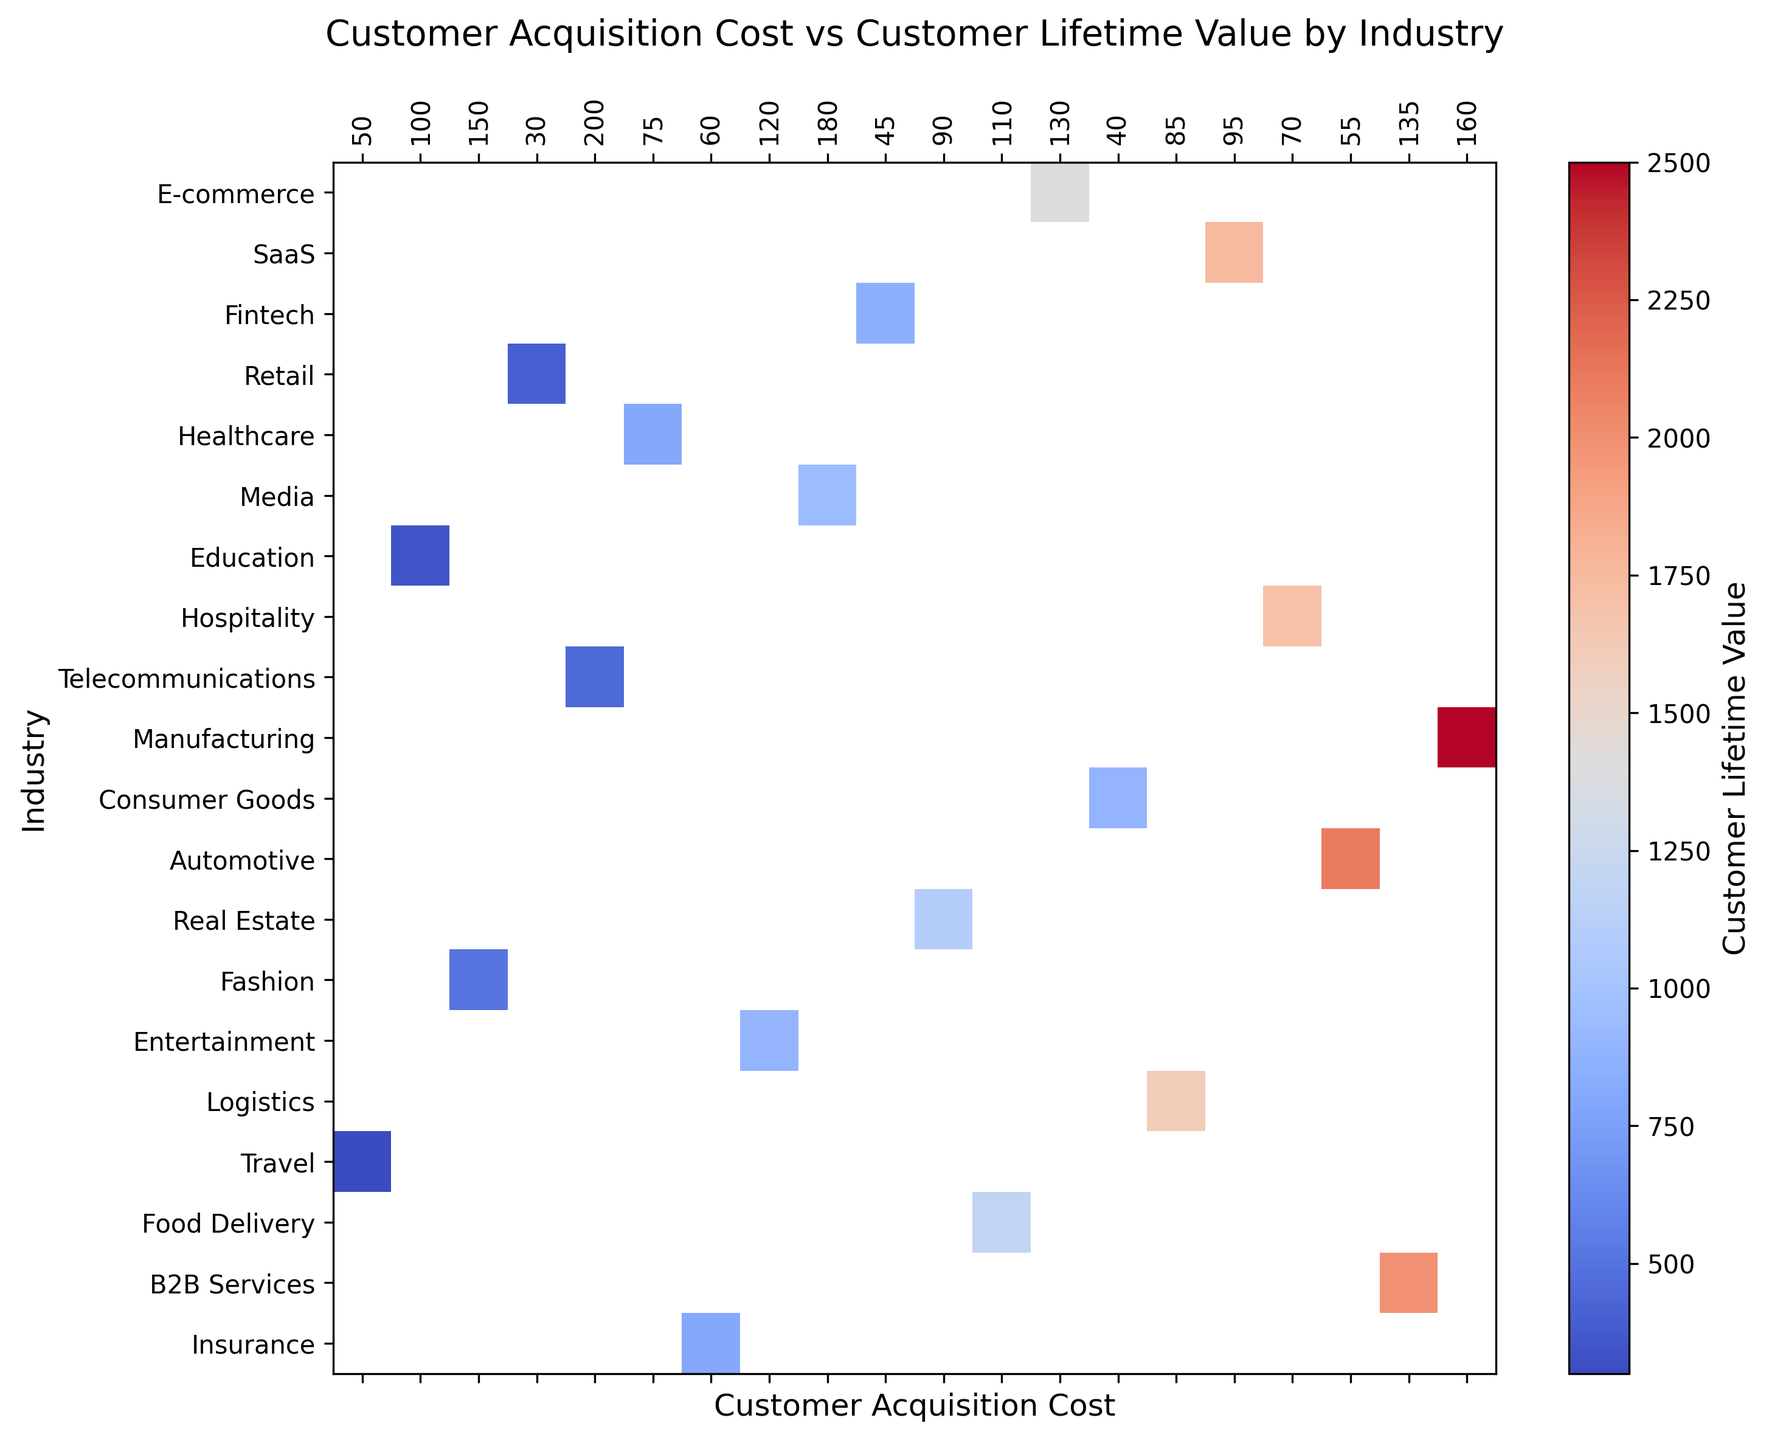What's the industry with the highest customer lifetime value? By examining the heatmap, you need to find the industry with the darkest color, which represents the highest customer lifetime value. The color bar on the right provides a legend for interpreting the color intensities.
Answer: Healthcare Which industry has the lowest customer acquisition cost? Look for the industry on the y-axis where the heatmap intersects with the lowest value on the x-axis for customer acquisition cost. This is the leftmost column.
Answer: Retail How does the customer lifetime value of Telecommunications compare to Real Estate? Identify both industries on the y-axis, then compare the color intensity of their respective heatmap cells at the intersection with their customer acquisition costs. Darker colors represent higher values.
Answer: Telecommunications has a higher customer lifetime value than Real Estate What's the average customer lifetime value for industries with a customer acquisition cost below 100? Determine which columns correspond to customer acquisition costs below 100, then find the average of the customer lifetime values represented by those columns.
Answer: (400 + 300 + 900 + 500 + 850 + 350 + 450)/7 = 535.71 Which industry in the heatmap has the most similar customer acquisition cost and customer lifetime value compared to Logistics? Locate Logistics on the y-axis, check its corresponding cell, and then find another industry with a similar cell color for both acquisition cost and lifetime value.
Answer: Travel Are there more industries with customer acquisition costs above 100 or below 100? Count the number of industries in columns with customer acquisition costs above and below 100. Compare these two counts.
Answer: Below 100 Which industry has a better ratio of customer lifetime value to customer acquisition cost, Education or Travel? Calculate the ratio for both industries. For Education: 800/60 = 13.33; For Travel: 800/70 = 11.43. Education has a higher ratio.
Answer: Education What is the difference in customer lifetime value between E-commerce and Fashion? Locate both industries on the heatmap, then subtract the customer lifetime value of Fashion from that of E-commerce using their respective colors.
Answer: 400 - 350 = 50 